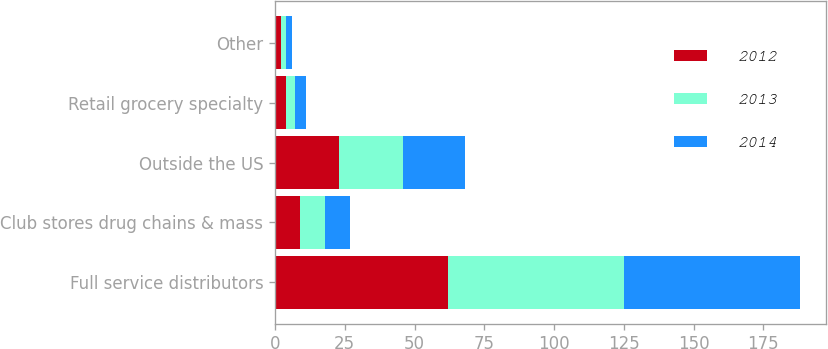<chart> <loc_0><loc_0><loc_500><loc_500><stacked_bar_chart><ecel><fcel>Full service distributors<fcel>Club stores drug chains & mass<fcel>Outside the US<fcel>Retail grocery specialty<fcel>Other<nl><fcel>2012<fcel>62<fcel>9<fcel>23<fcel>4<fcel>2<nl><fcel>2013<fcel>63<fcel>9<fcel>23<fcel>3<fcel>2<nl><fcel>2014<fcel>63<fcel>9<fcel>22<fcel>4<fcel>2<nl></chart> 